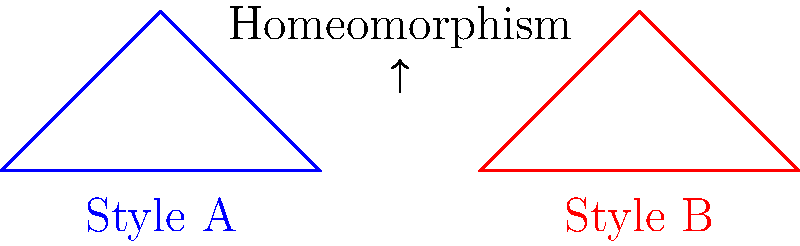Consider two distinct styles in contemporary British ceramics, represented by the triangular shapes above. If these styles can be continuously deformed into one another without tearing or gluing, what topological property do they share? To determine the topological property shared by these two ceramic styles, we need to consider the concept of homeomorphism in topology. Let's break it down step-by-step:

1. Homeomorphism: In topology, two objects are considered homeomorphic if one can be deformed into the other without cutting, tearing, or gluing.

2. Shape analysis: Both styles are represented by triangular shapes. Triangles are simple closed curves in a 2D plane.

3. Topological properties:
   a) Both shapes have the same number of vertices (3)
   b) Both shapes have the same number of edges (3)
   c) Both shapes enclose a single region

4. Continuous deformation: We can imagine stretching or shrinking one triangle to match the other without breaking the curve or creating new connections.

5. Invariant property: The key topological property that remains unchanged during this transformation is the genus, which represents the number of "holes" in the shape.

6. Genus calculation: For a simple closed curve in a plane, the genus is always 0.

Therefore, the topological property shared by these two ceramic styles is that they both have a genus of 0, making them homeomorphic to each other and to all simple closed curves in a plane.
Answer: Genus 0 